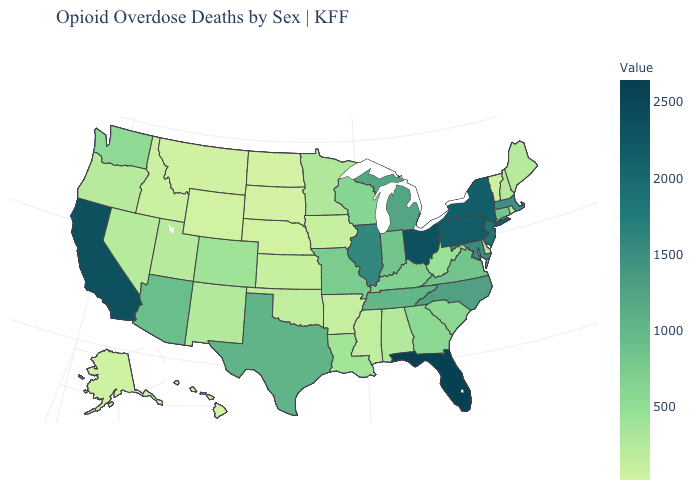Does New Jersey have a higher value than California?
Be succinct. No. Which states have the lowest value in the Northeast?
Answer briefly. Vermont. Which states hav the highest value in the South?
Be succinct. Florida. Which states have the highest value in the USA?
Keep it brief. Florida. Which states have the lowest value in the USA?
Short answer required. South Dakota. Is the legend a continuous bar?
Concise answer only. Yes. Among the states that border Oregon , which have the lowest value?
Answer briefly. Idaho. Which states have the highest value in the USA?
Concise answer only. Florida. Which states have the highest value in the USA?
Quick response, please. Florida. 